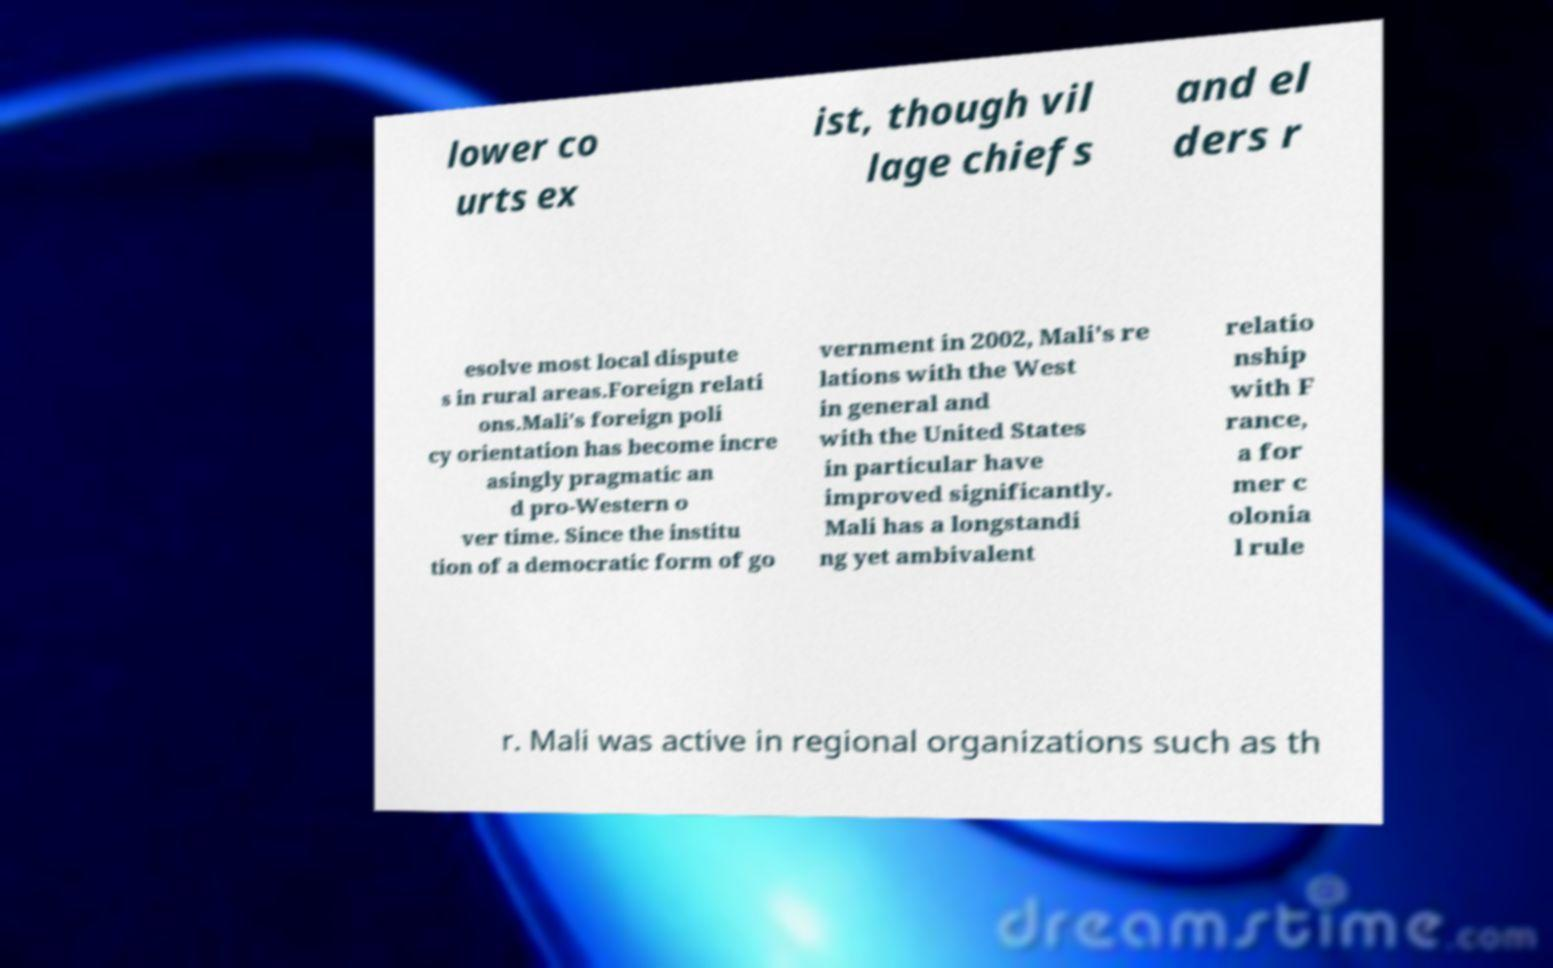Can you read and provide the text displayed in the image?This photo seems to have some interesting text. Can you extract and type it out for me? lower co urts ex ist, though vil lage chiefs and el ders r esolve most local dispute s in rural areas.Foreign relati ons.Mali's foreign poli cy orientation has become incre asingly pragmatic an d pro-Western o ver time. Since the institu tion of a democratic form of go vernment in 2002, Mali's re lations with the West in general and with the United States in particular have improved significantly. Mali has a longstandi ng yet ambivalent relatio nship with F rance, a for mer c olonia l rule r. Mali was active in regional organizations such as th 